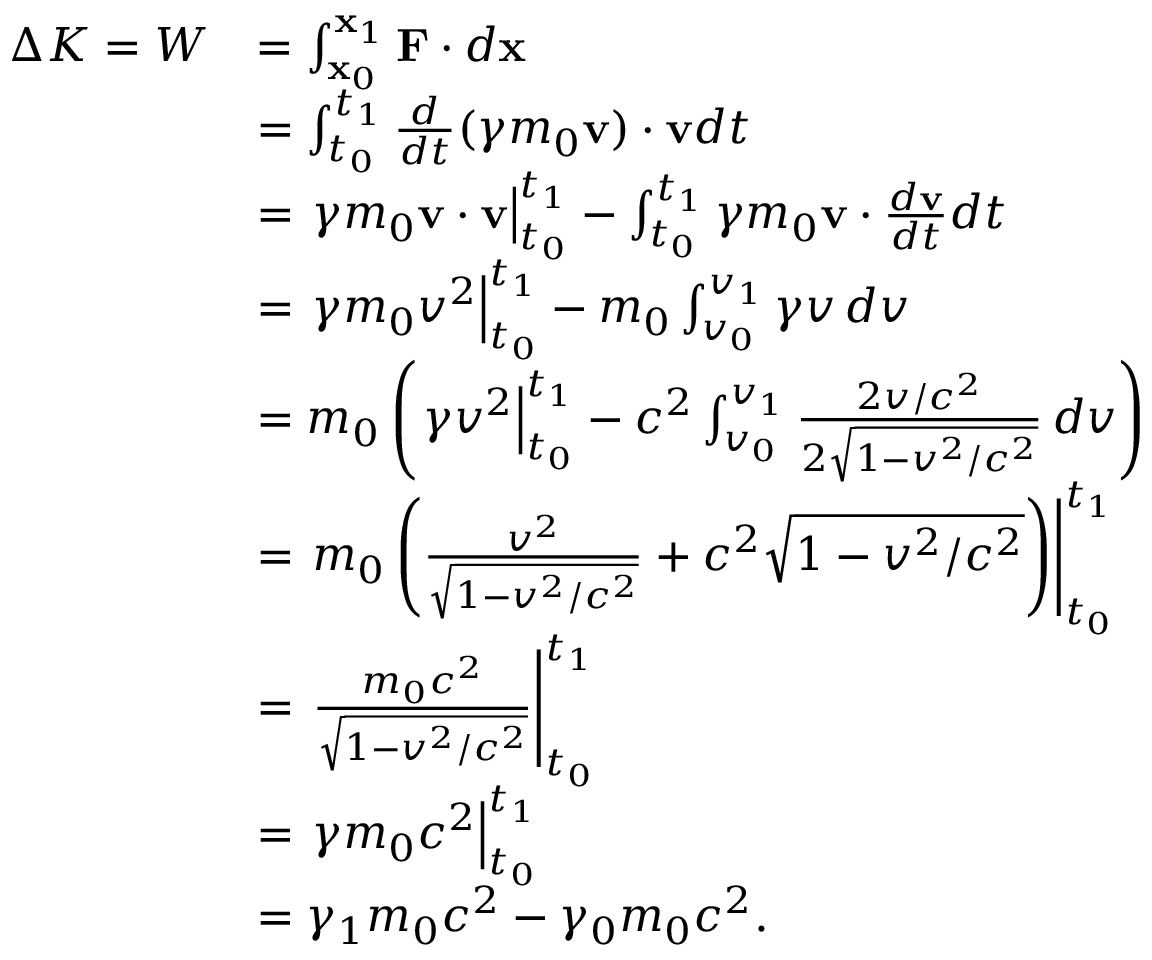Convert formula to latex. <formula><loc_0><loc_0><loc_500><loc_500>{ \begin{array} { r l } { \Delta K = W } & { = \int _ { x _ { 0 } } ^ { x _ { 1 } } F \cdot d x } \\ & { = \int _ { t _ { 0 } } ^ { t _ { 1 } } { \frac { d } { d t } } ( \gamma m _ { 0 } v ) \cdot v d t } \\ & { = \gamma m _ { 0 } v \cdot v \right | _ { t _ { 0 } } ^ { t _ { 1 } } - \int _ { t _ { 0 } } ^ { t _ { 1 } } \gamma m _ { 0 } v \cdot { \frac { d v } { d t } } d t } \\ & { = \gamma m _ { 0 } v ^ { 2 } \right | _ { t _ { 0 } } ^ { t _ { 1 } } - m _ { 0 } \int _ { v _ { 0 } } ^ { v _ { 1 } } \gamma v \, d v } \\ & { = m _ { 0 } \left ( \gamma v ^ { 2 } \right | _ { t _ { 0 } } ^ { t _ { 1 } } - c ^ { 2 } \int _ { v _ { 0 } } ^ { v _ { 1 } } { \frac { 2 v / c ^ { 2 } } { 2 { \sqrt { 1 - v ^ { 2 } / c ^ { 2 } } } } } \, d v \right ) } \\ & { = m _ { 0 } \left ( { \frac { v ^ { 2 } } { \sqrt { 1 - v ^ { 2 } / c ^ { 2 } } } } + c ^ { 2 } { \sqrt { 1 - v ^ { 2 } / c ^ { 2 } } } \right ) \right | _ { t _ { 0 } } ^ { t _ { 1 } } } \\ & { = { \frac { m _ { 0 } c ^ { 2 } } { \sqrt { 1 - v ^ { 2 } / c ^ { 2 } } } } \right | _ { t _ { 0 } } ^ { t _ { 1 } } } \\ & { = { \gamma m _ { 0 } c ^ { 2 } } \right | _ { t _ { 0 } } ^ { t _ { 1 } } } \\ & { = \gamma _ { 1 } m _ { 0 } c ^ { 2 } - \gamma _ { 0 } m _ { 0 } c ^ { 2 } . } \end{array} }</formula> 